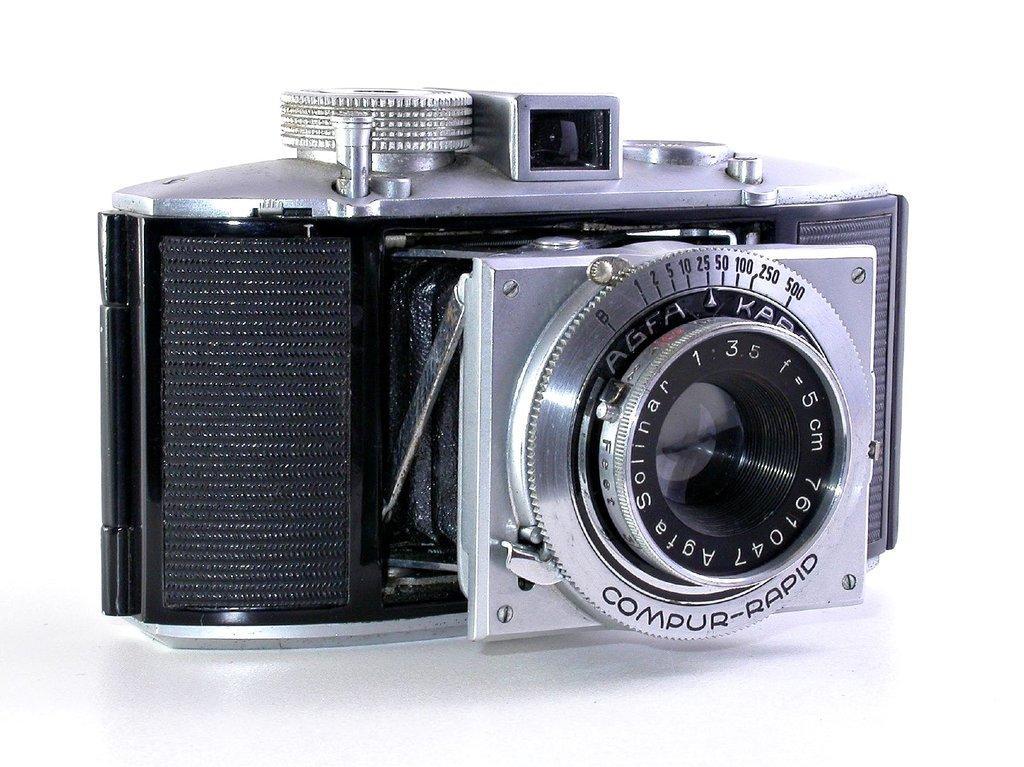Could you give a brief overview of what you see in this image? In the image there is a camera and the background is in white color. 